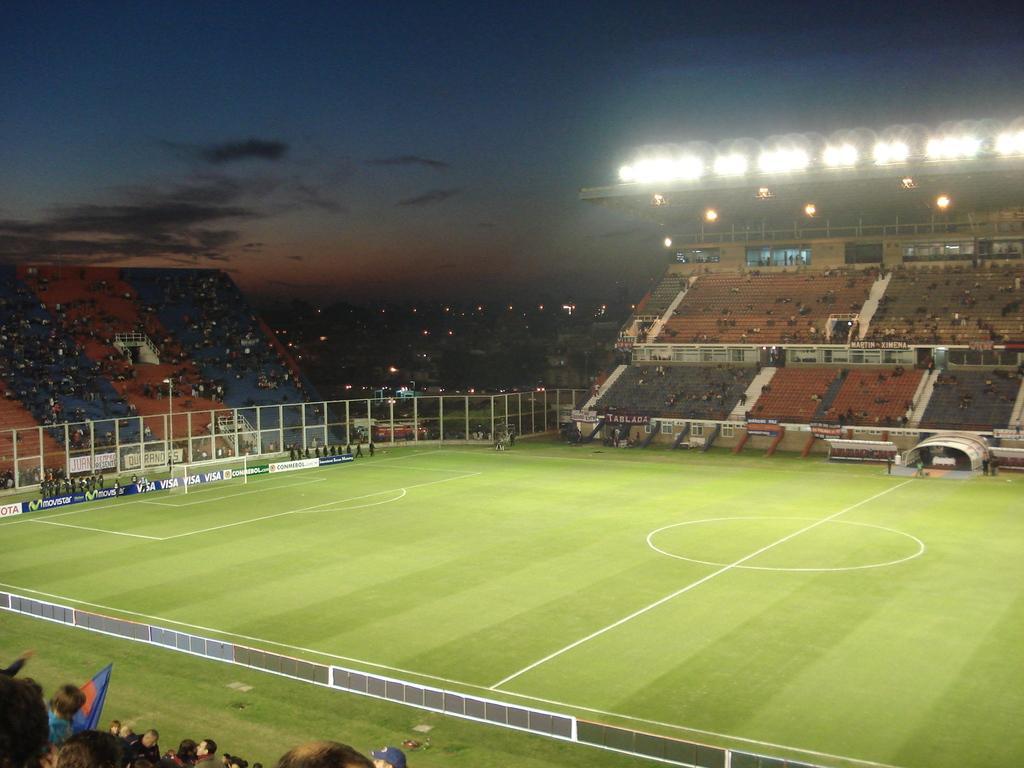Can you describe this image briefly? This is clicked in a football stadium, there is grass field in the middle with audience sitting around it on chairs and looking at the game and above its sky with clouds. 